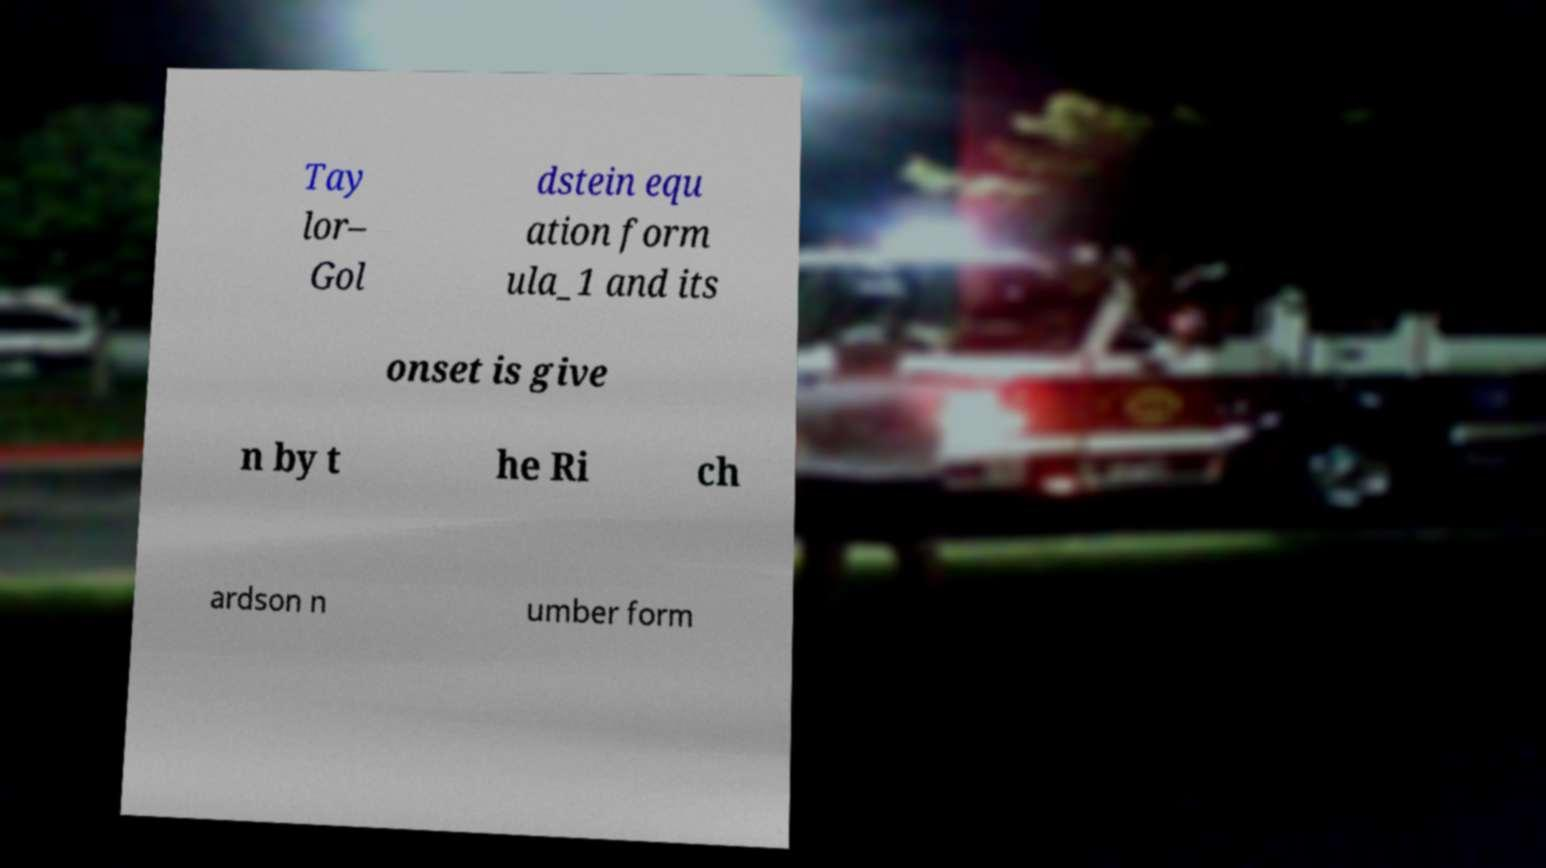Could you extract and type out the text from this image? Tay lor– Gol dstein equ ation form ula_1 and its onset is give n by t he Ri ch ardson n umber form 